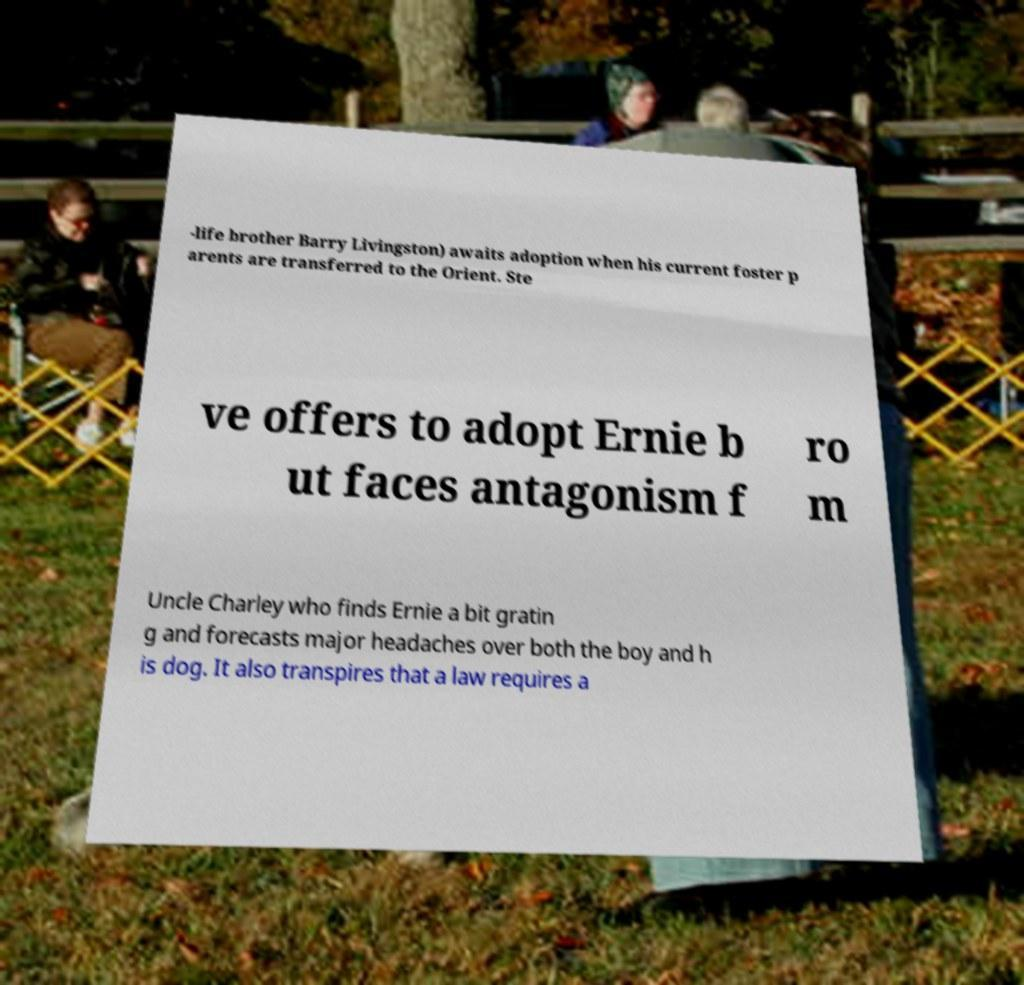There's text embedded in this image that I need extracted. Can you transcribe it verbatim? -life brother Barry Livingston) awaits adoption when his current foster p arents are transferred to the Orient. Ste ve offers to adopt Ernie b ut faces antagonism f ro m Uncle Charley who finds Ernie a bit gratin g and forecasts major headaches over both the boy and h is dog. It also transpires that a law requires a 